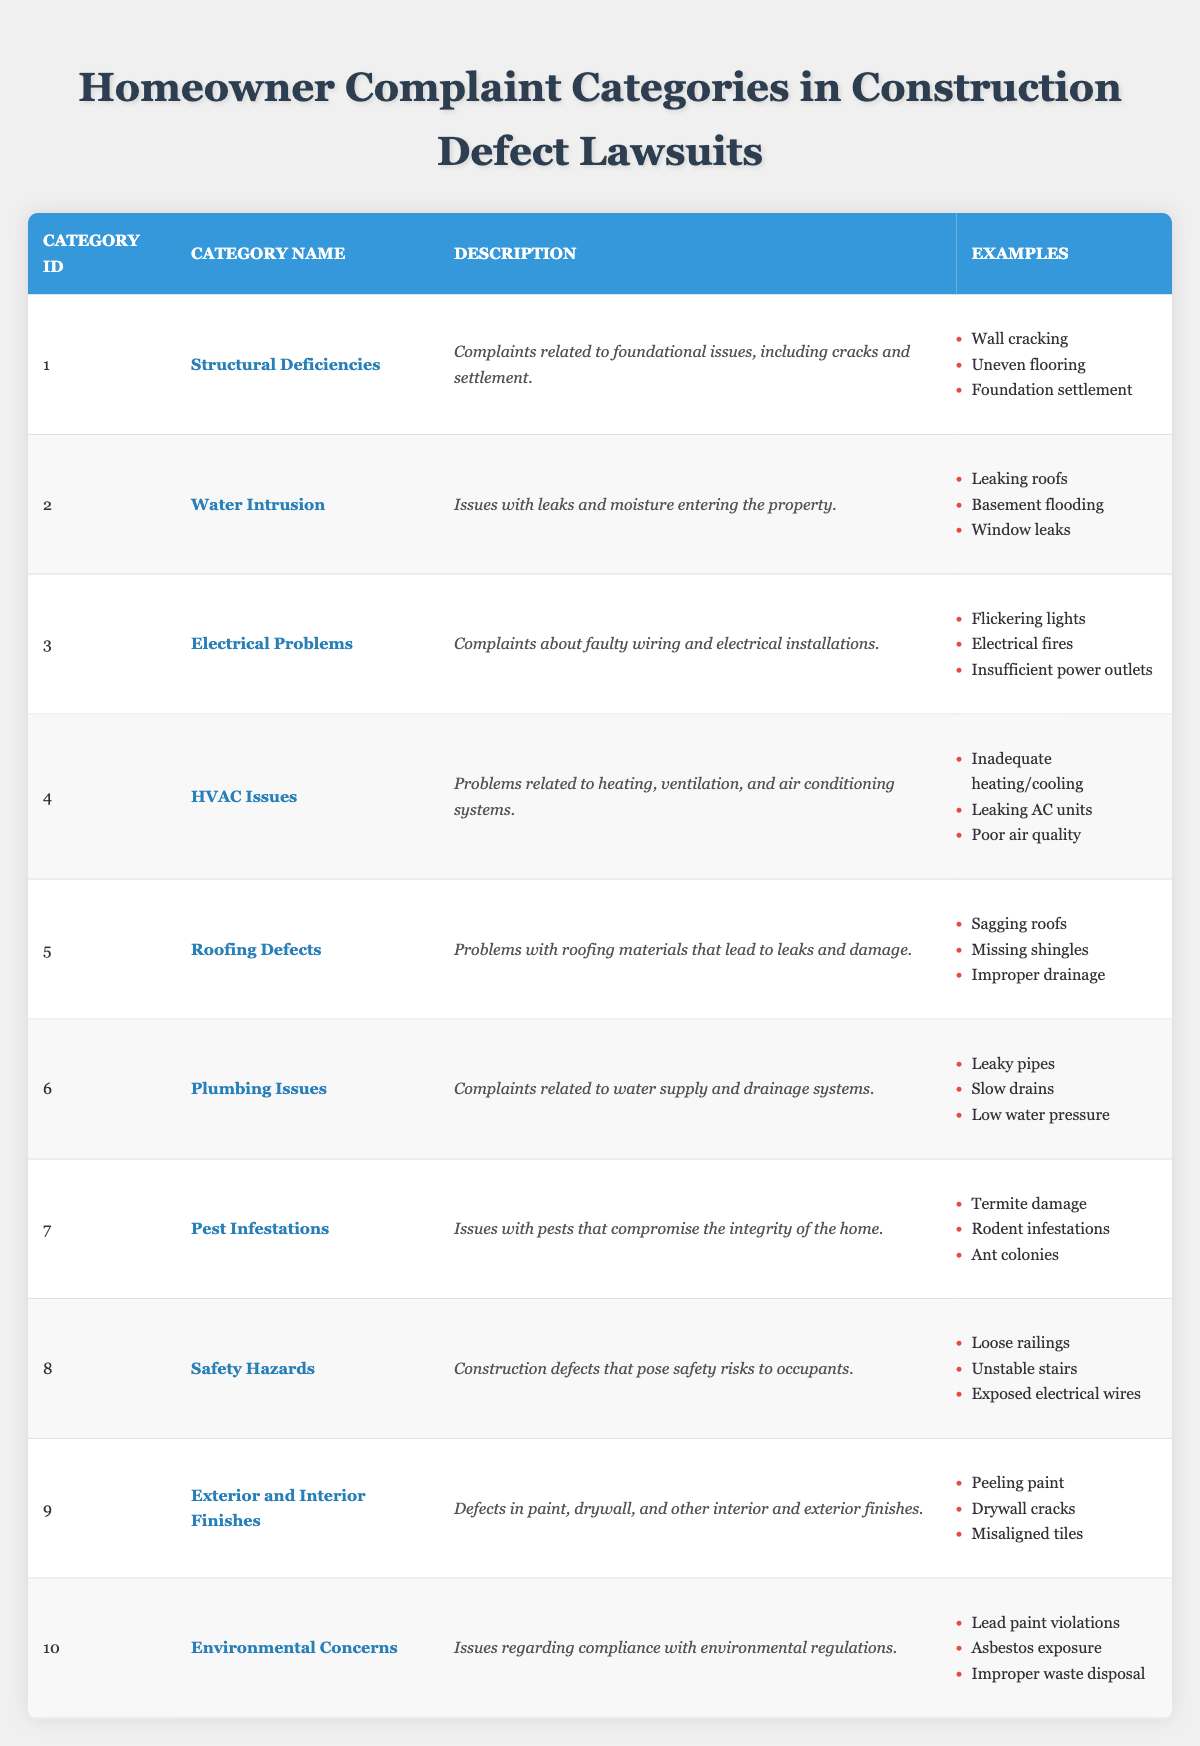What is the category name for Category ID 1? Referring to the table, the entry with Category ID 1 has the category name "Structural Deficiencies."
Answer: Structural Deficiencies How many different examples are listed for "Roofing Defects"? In the row for "Roofing Defects," there are three examples provided: "Sagging roofs," "Missing shingles," and "Improper drainage."
Answer: 3 Is "Leaky pipes" an example of "Plumbing Issues"? According to the table, "Leaky pipes" is explicitly listed as an example under the "Plumbing Issues" category.
Answer: Yes What are the major complaints in the "Electrical Problems" category? The "Electrical Problems" category includes three major complaints: "Flickering lights," "Electrical fires," and "Insufficient power outlets."
Answer: Flickering lights, Electrical fires, Insufficient power outlets Which category includes complaints about environmental regulations? By reviewing the descriptions in the table, the category that explicitly refers to environmental issues is "Environmental Concerns."
Answer: Environmental Concerns Which complaint category has safety hazards as its focus? The table describes "Safety Hazards" as construction defects posing risks to occupants, making it the relevant category.
Answer: Safety Hazards How many categories address issues related to plumbing or water supply? There are two categories that address plumbing or water supply issues: "Plumbing Issues" and "Water Intrusion." Therefore, the count is calculated as 2.
Answer: 2 What is the description for "Pest Infestations"? The table states that "Pest Infestations" concerns issues with pests that compromise the integrity of the home.
Answer: Issues with pests that compromise the integrity of the home Are "Drywall cracks" and "Peeling paint" part of the same complaint category? By examining the examples listed, "Drywall cracks" belongs to the "Exterior and Interior Finishes" category, while "Peeling paint" is also included in the same category, confirming their association.
Answer: Yes Which category combines issues related to HVAC systems, and what are the examples? The "HVAC Issues" category combines problems related to heating, ventilation, and air conditioning systems, with examples like "Inadequate heating/cooling," "Leaking AC units," and "Poor air quality."
Answer: HVAC Issues, Inadequate heating/cooling, Leaking AC units, Poor air quality 